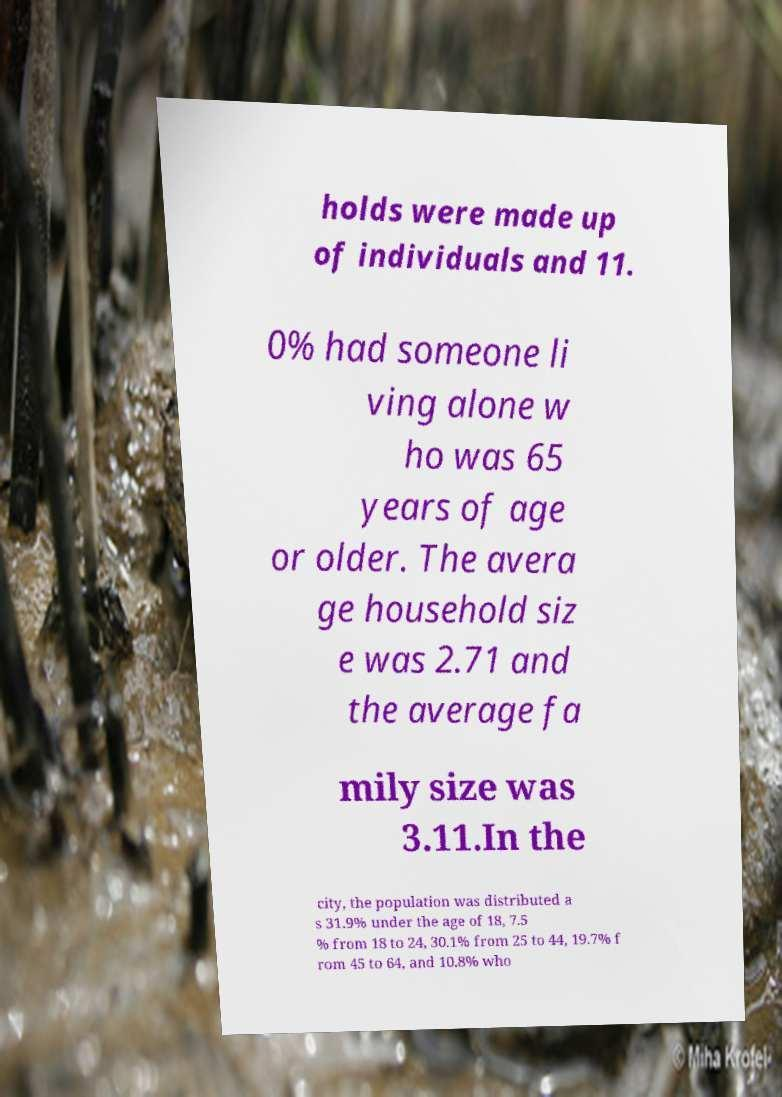Can you accurately transcribe the text from the provided image for me? holds were made up of individuals and 11. 0% had someone li ving alone w ho was 65 years of age or older. The avera ge household siz e was 2.71 and the average fa mily size was 3.11.In the city, the population was distributed a s 31.9% under the age of 18, 7.5 % from 18 to 24, 30.1% from 25 to 44, 19.7% f rom 45 to 64, and 10.8% who 